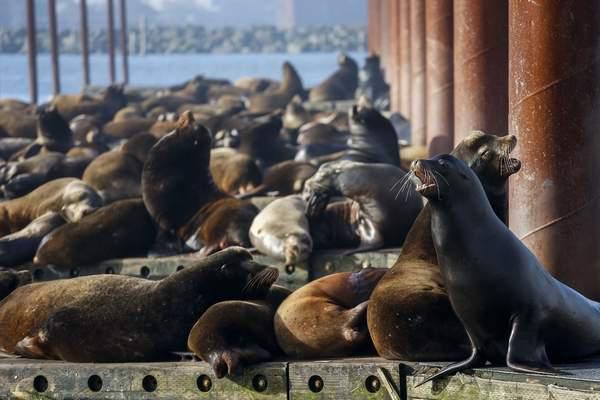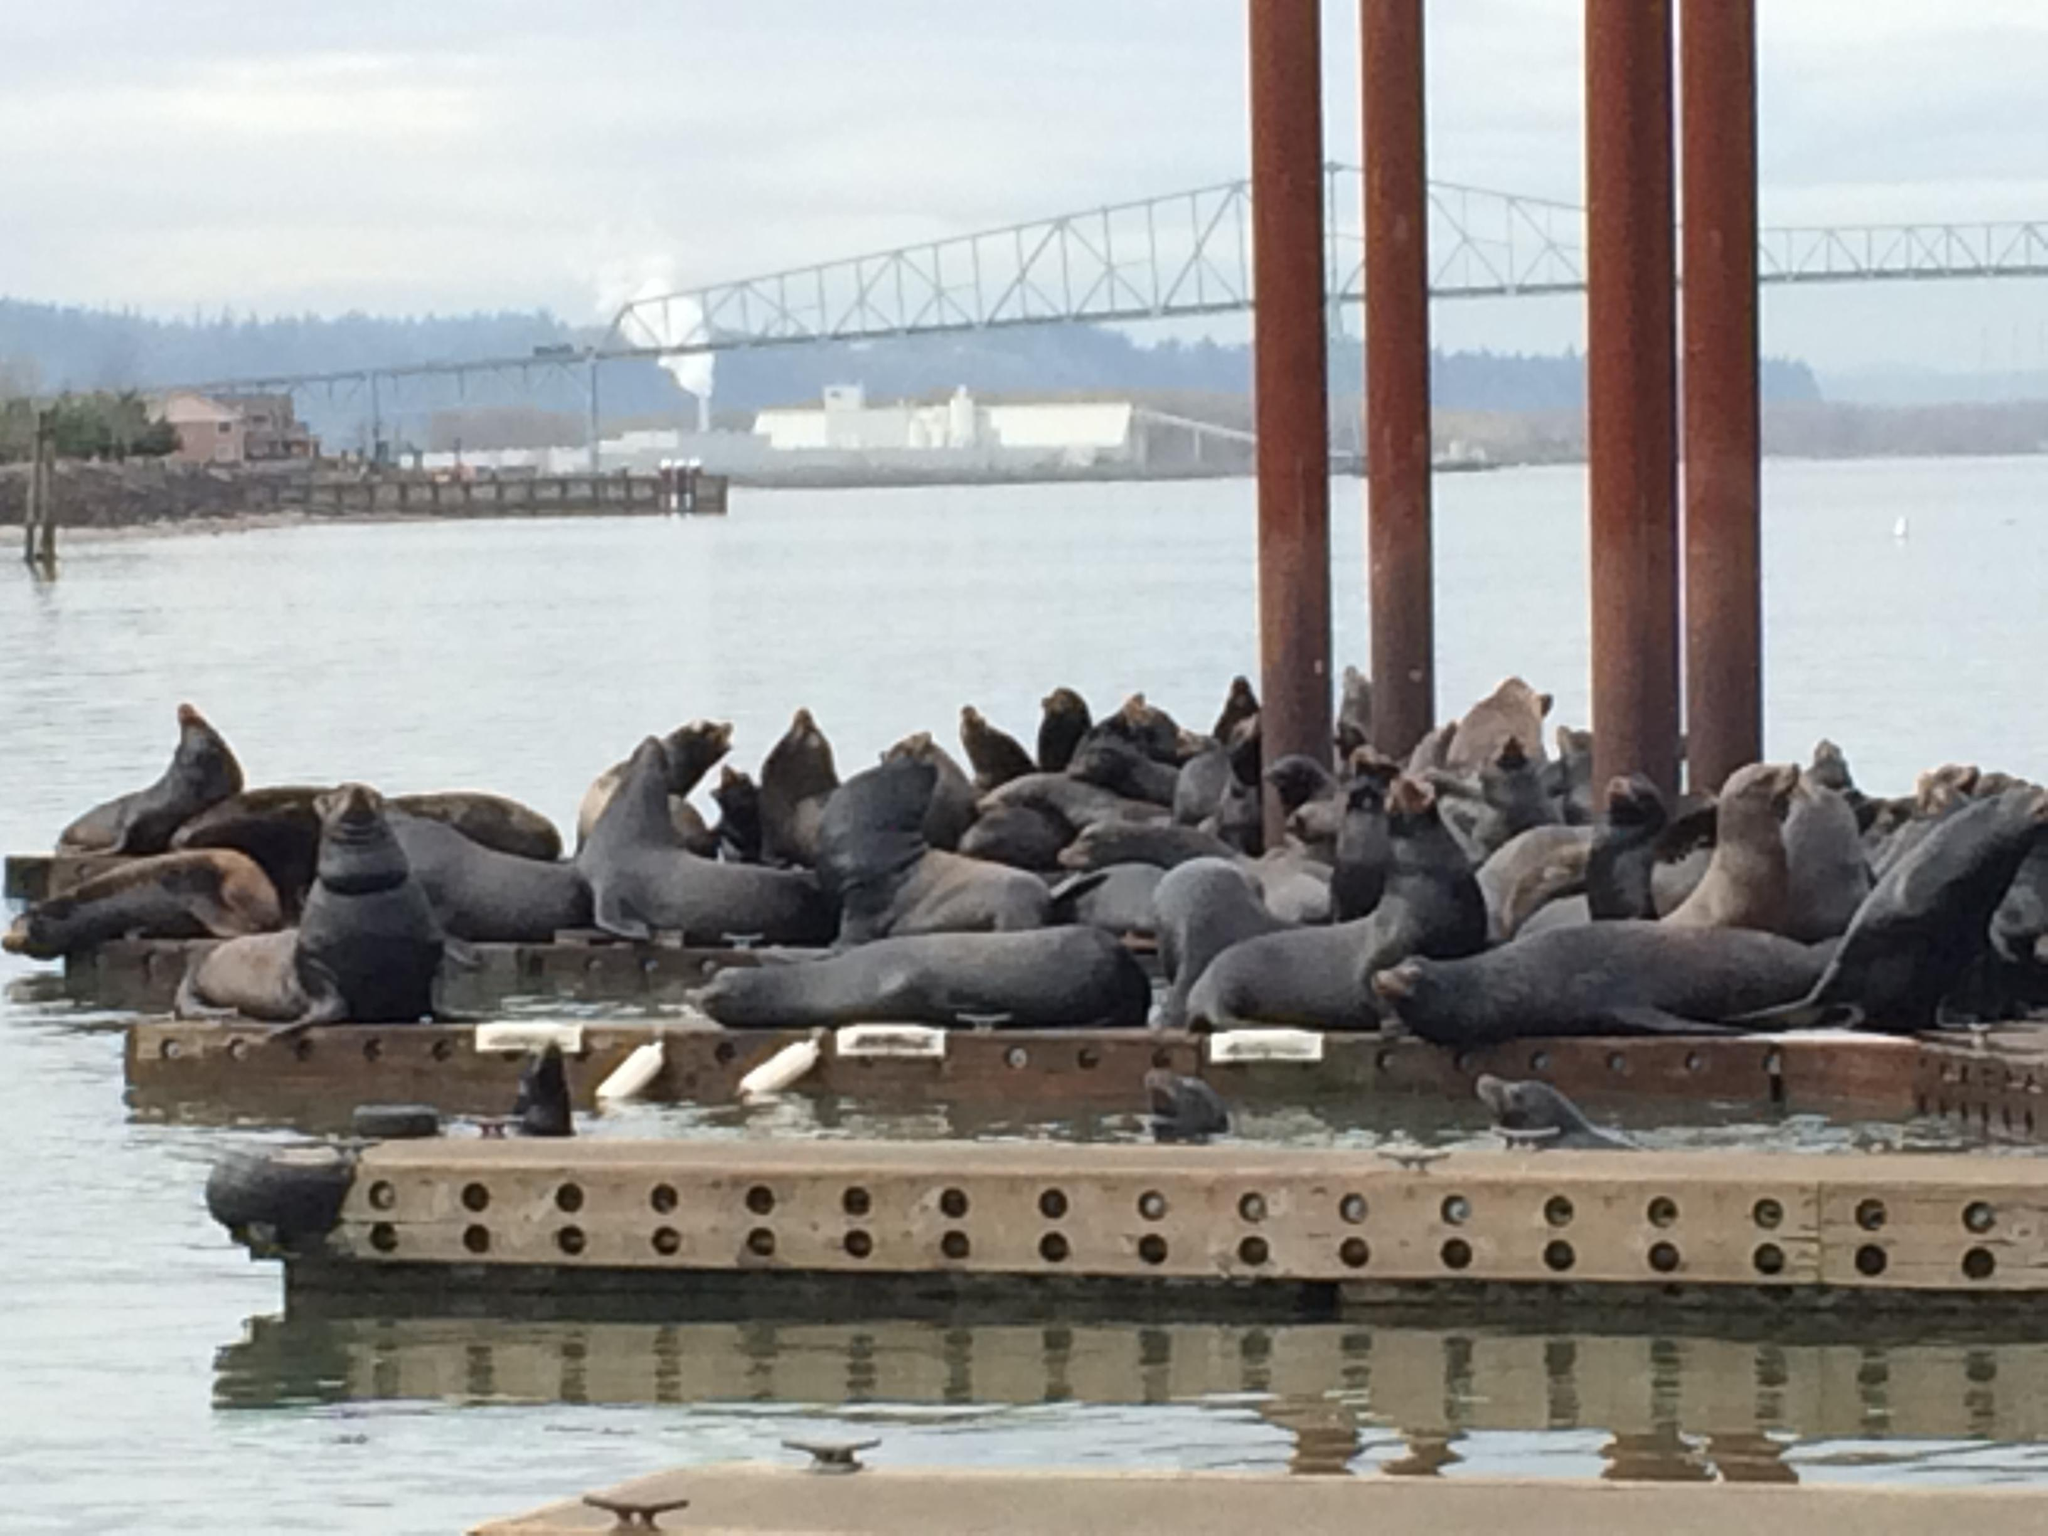The first image is the image on the left, the second image is the image on the right. Analyze the images presented: Is the assertion "In at least one of the images, there are visible holes in the edges of the floating dock." valid? Answer yes or no. Yes. The first image is the image on the left, the second image is the image on the right. Assess this claim about the two images: "Each image shows a mass of seals on a platform with brown vertical columns.". Correct or not? Answer yes or no. Yes. 